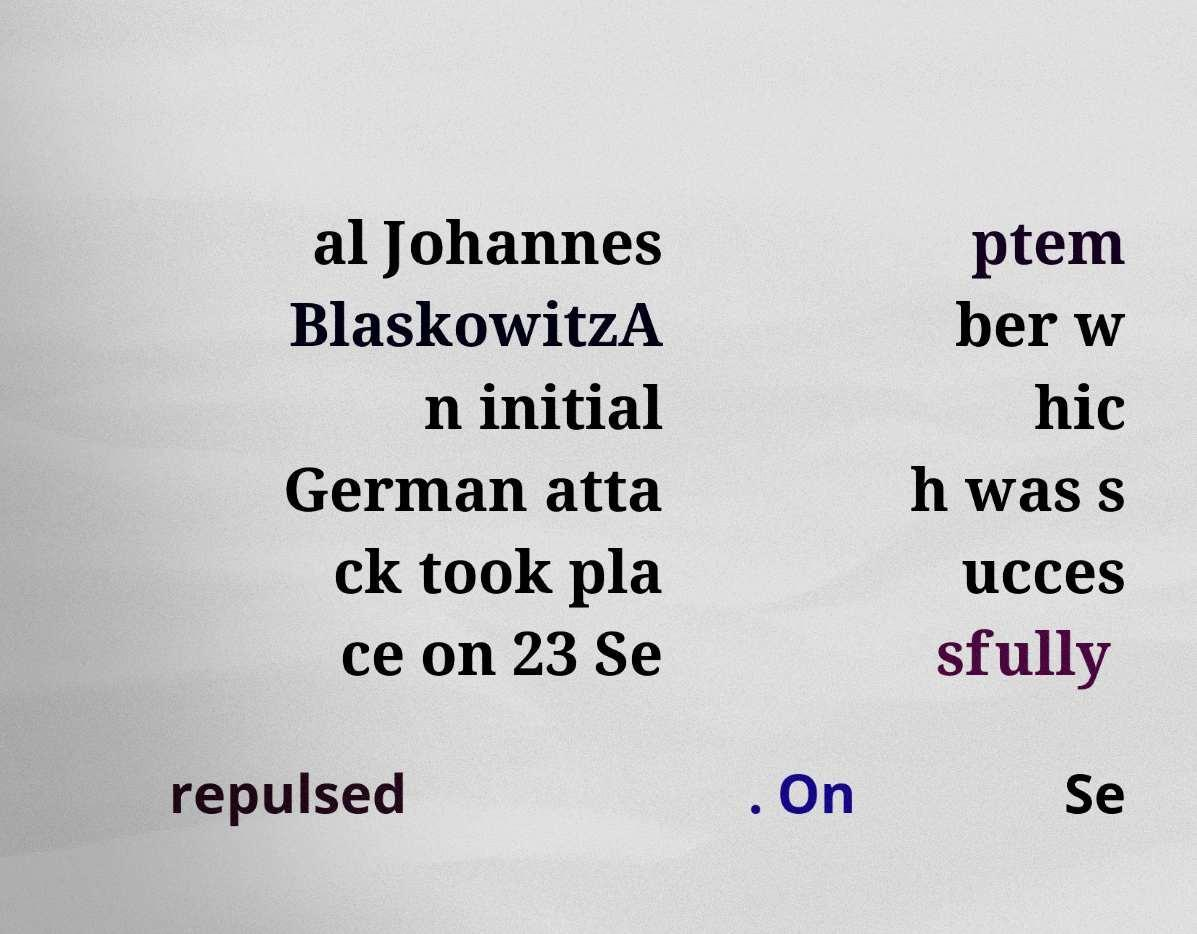Can you accurately transcribe the text from the provided image for me? al Johannes BlaskowitzA n initial German atta ck took pla ce on 23 Se ptem ber w hic h was s ucces sfully repulsed . On Se 